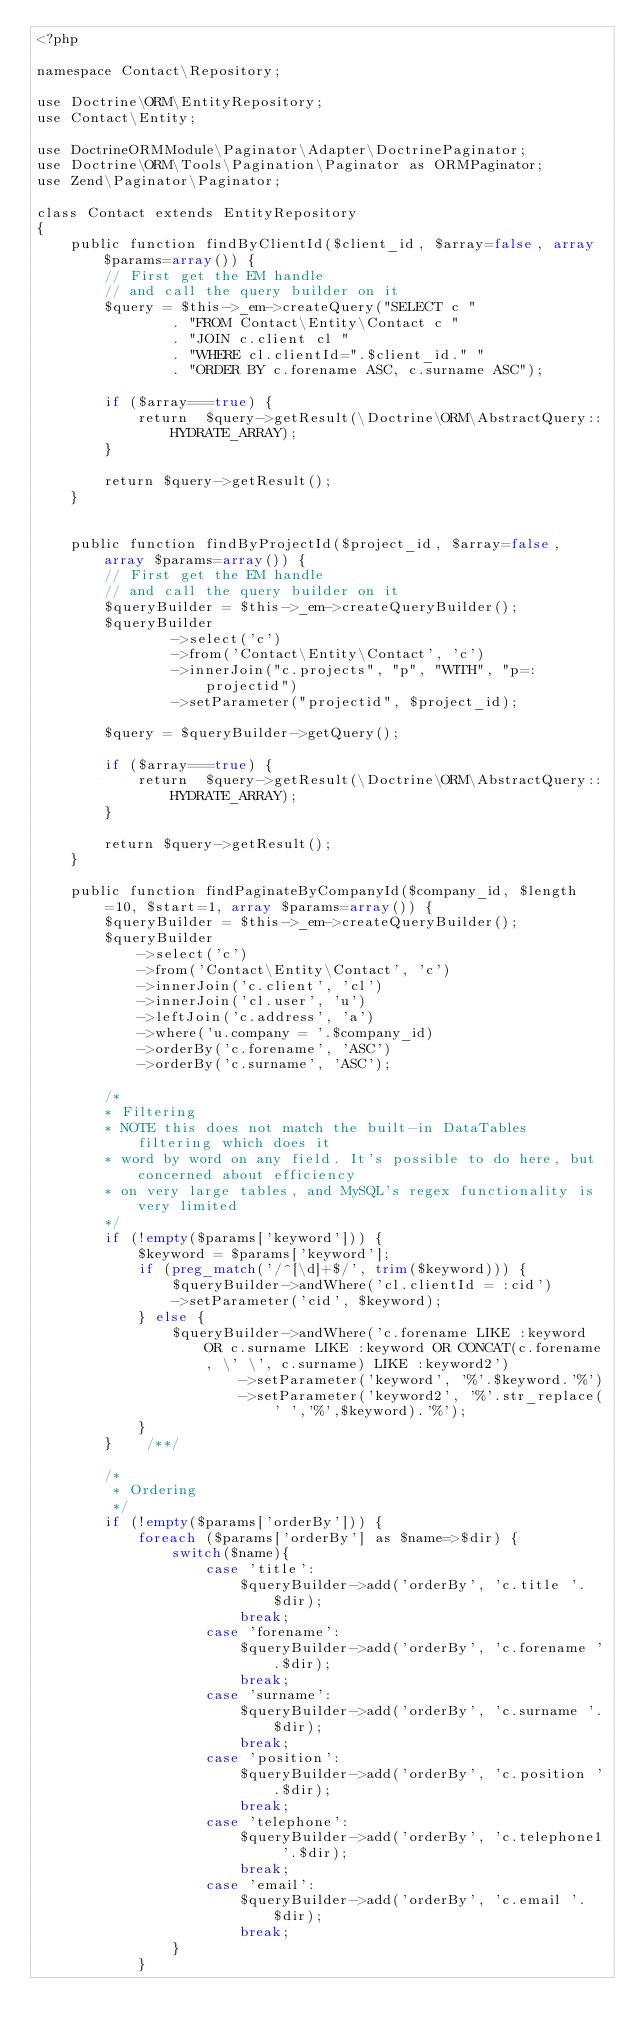<code> <loc_0><loc_0><loc_500><loc_500><_PHP_><?php

namespace Contact\Repository;
 
use Doctrine\ORM\EntityRepository;
use Contact\Entity;

use DoctrineORMModule\Paginator\Adapter\DoctrinePaginator;
use Doctrine\ORM\Tools\Pagination\Paginator as ORMPaginator;
use Zend\Paginator\Paginator;
 
class Contact extends EntityRepository
{
    public function findByClientId($client_id, $array=false, array $params=array()) {
        // First get the EM handle
        // and call the query builder on it
        $query = $this->_em->createQuery("SELECT c "
                . "FROM Contact\Entity\Contact c "
                . "JOIN c.client cl "
                . "WHERE cl.clientId=".$client_id." "
                . "ORDER BY c.forename ASC, c.surname ASC");
        
        if ($array===true) {
            return  $query->getResult(\Doctrine\ORM\AbstractQuery::HYDRATE_ARRAY);
        }
        
        return $query->getResult();
    }
    
    
    public function findByProjectId($project_id, $array=false, array $params=array()) {
        // First get the EM handle
        // and call the query builder on it
        $queryBuilder = $this->_em->createQueryBuilder();
        $queryBuilder
                ->select('c')
                ->from('Contact\Entity\Contact', 'c')
                ->innerJoin("c.projects", "p", "WITH", "p=:projectid")
                ->setParameter("projectid", $project_id);

        $query = $queryBuilder->getQuery();
        
        if ($array===true) {
            return  $query->getResult(\Doctrine\ORM\AbstractQuery::HYDRATE_ARRAY);
        }
        
        return $query->getResult();
    }
    
    public function findPaginateByCompanyId($company_id, $length=10, $start=1, array $params=array()) {
        $queryBuilder = $this->_em->createQueryBuilder();
        $queryBuilder
            ->select('c')
            ->from('Contact\Entity\Contact', 'c')
            ->innerJoin('c.client', 'cl')
            ->innerJoin('cl.user', 'u')
            ->leftJoin('c.address', 'a')
            ->where('u.company = '.$company_id)
            ->orderBy('c.forename', 'ASC')
            ->orderBy('c.surname', 'ASC');
        
        /* 
        * Filtering
        * NOTE this does not match the built-in DataTables filtering which does it
        * word by word on any field. It's possible to do here, but concerned about efficiency
        * on very large tables, and MySQL's regex functionality is very limited
        */
        if (!empty($params['keyword'])) {
            $keyword = $params['keyword'];
            if (preg_match('/^[\d]+$/', trim($keyword))) {
                $queryBuilder->andWhere('cl.clientId = :cid')
                ->setParameter('cid', $keyword);
            } else {
                $queryBuilder->andWhere('c.forename LIKE :keyword OR c.surname LIKE :keyword OR CONCAT(c.forename, \' \', c.surname) LIKE :keyword2')
                        ->setParameter('keyword', '%'.$keyword.'%')
                        ->setParameter('keyword2', '%'.str_replace(' ','%',$keyword).'%');
            }
        }    /**/    
        
        /*
         * Ordering
         */
        if (!empty($params['orderBy'])) {
            foreach ($params['orderBy'] as $name=>$dir) {
                switch($name){
                    case 'title':
                        $queryBuilder->add('orderBy', 'c.title '.$dir);
                        break;
                    case 'forename':
                        $queryBuilder->add('orderBy', 'c.forename '.$dir);
                        break;
                    case 'surname':
                        $queryBuilder->add('orderBy', 'c.surname '.$dir);
                        break;
                    case 'position':
                        $queryBuilder->add('orderBy', 'c.position '.$dir);
                        break;
                    case 'telephone':
                        $queryBuilder->add('orderBy', 'c.telephone1 '.$dir);
                        break;
                    case 'email':
                        $queryBuilder->add('orderBy', 'c.email '.$dir);
                        break;
                }
            }</code> 